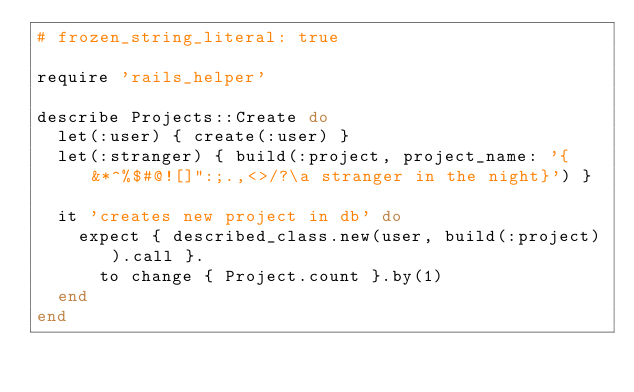<code> <loc_0><loc_0><loc_500><loc_500><_Ruby_># frozen_string_literal: true

require 'rails_helper'

describe Projects::Create do
  let(:user) { create(:user) }
  let(:stranger) { build(:project, project_name: '{ &*^%$#@![]":;.,<>/?\a stranger in the night}') }

  it 'creates new project in db' do
    expect { described_class.new(user, build(:project)).call }.
      to change { Project.count }.by(1)
  end
end
</code> 